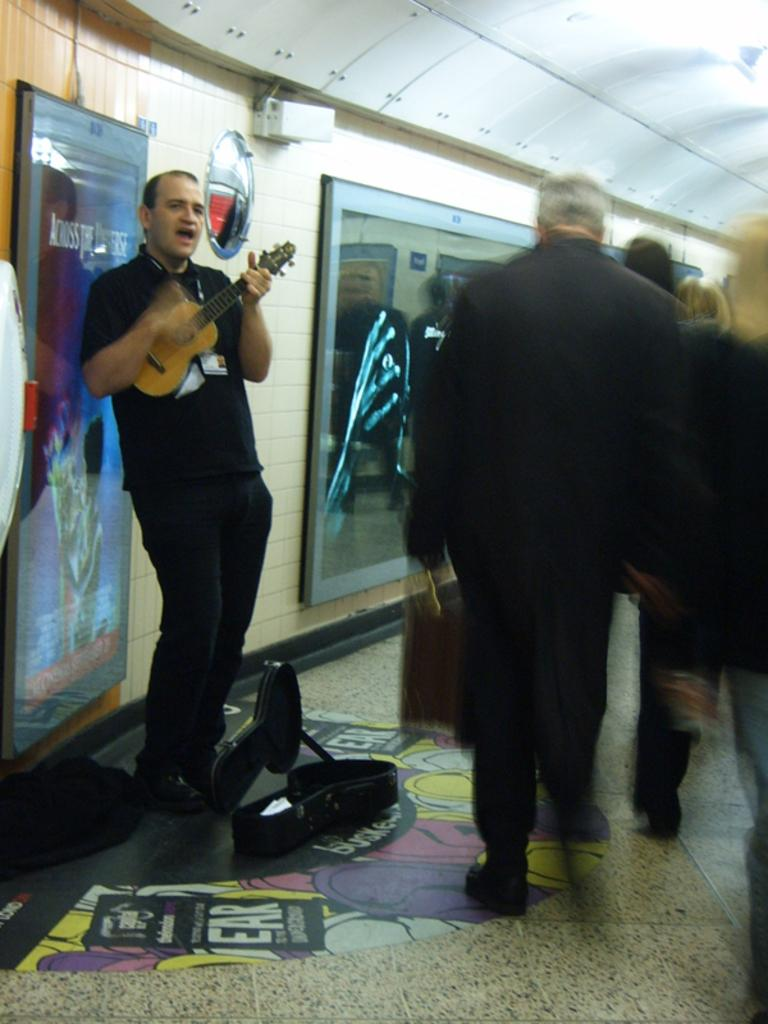What is happening in the image involving a group of persons? There is a group of persons walking in the image. Where are the persons walking in the image? The group of persons is on the right side of the image. Can you describe the person in the middle of the image? The person in the middle is wearing a black color dress and is playing a guitar. What type of ring is the grandmother wearing in the image? There is no grandmother or ring present in the image. How does the car affect the group of persons walking in the image? There is no car present in the image, so it cannot affect the group of persons walking. 